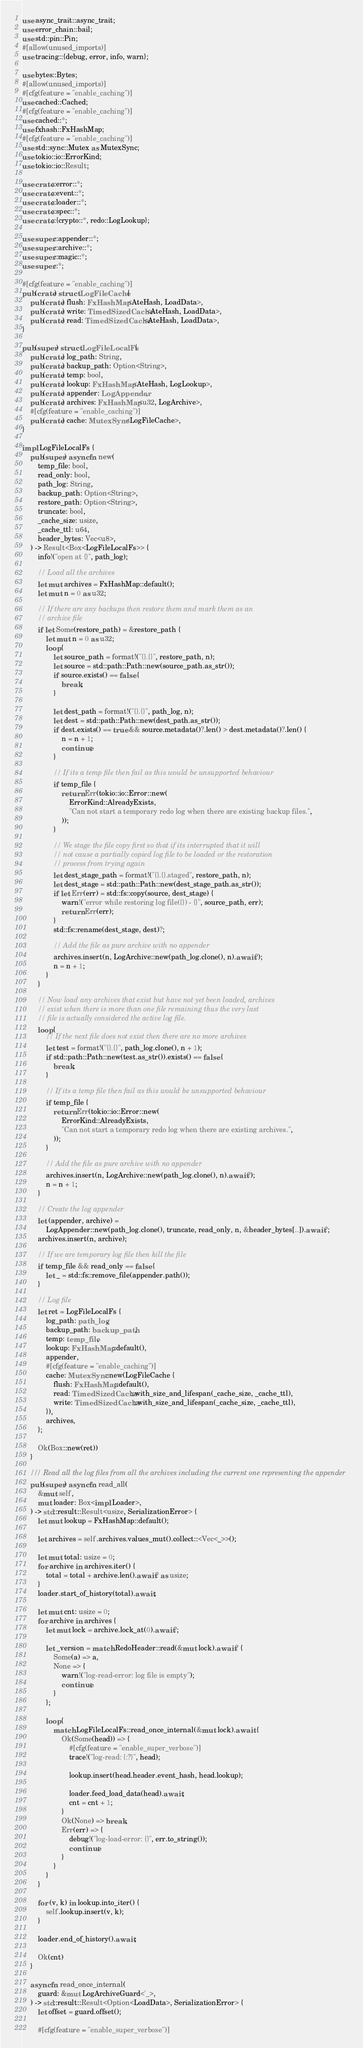Convert code to text. <code><loc_0><loc_0><loc_500><loc_500><_Rust_>use async_trait::async_trait;
use error_chain::bail;
use std::pin::Pin;
#[allow(unused_imports)]
use tracing::{debug, error, info, warn};

use bytes::Bytes;
#[allow(unused_imports)]
#[cfg(feature = "enable_caching")]
use cached::Cached;
#[cfg(feature = "enable_caching")]
use cached::*;
use fxhash::FxHashMap;
#[cfg(feature = "enable_caching")]
use std::sync::Mutex as MutexSync;
use tokio::io::ErrorKind;
use tokio::io::Result;

use crate::error::*;
use crate::event::*;
use crate::loader::*;
use crate::spec::*;
use crate::{crypto::*, redo::LogLookup};

use super::appender::*;
use super::archive::*;
use super::magic::*;
use super::*;

#[cfg(feature = "enable_caching")]
pub(crate) struct LogFileCache {
    pub(crate) flush: FxHashMap<AteHash, LoadData>,
    pub(crate) write: TimedSizedCache<AteHash, LoadData>,
    pub(crate) read: TimedSizedCache<AteHash, LoadData>,
}

pub(super) struct LogFileLocalFs {
    pub(crate) log_path: String,
    pub(crate) backup_path: Option<String>,
    pub(crate) temp: bool,
    pub(crate) lookup: FxHashMap<AteHash, LogLookup>,
    pub(crate) appender: LogAppender,
    pub(crate) archives: FxHashMap<u32, LogArchive>,
    #[cfg(feature = "enable_caching")]
    pub(crate) cache: MutexSync<LogFileCache>,
}

impl LogFileLocalFs {
    pub(super) async fn new(
        temp_file: bool,
        read_only: bool,
        path_log: String,
        backup_path: Option<String>,
        restore_path: Option<String>,
        truncate: bool,
        _cache_size: usize,
        _cache_ttl: u64,
        header_bytes: Vec<u8>,
    ) -> Result<Box<LogFileLocalFs>> {
        info!("open at {}", path_log);

        // Load all the archives
        let mut archives = FxHashMap::default();
        let mut n = 0 as u32;

        // If there are any backups then restore them and mark them as an
        // archive file
        if let Some(restore_path) = &restore_path {
            let mut n = 0 as u32;
            loop {
                let source_path = format!("{}.{}", restore_path, n);
                let source = std::path::Path::new(source_path.as_str());
                if source.exists() == false {
                    break;
                }

                let dest_path = format!("{}.{}", path_log, n);
                let dest = std::path::Path::new(dest_path.as_str());
                if dest.exists() == true && source.metadata()?.len() > dest.metadata()?.len() {
                    n = n + 1;
                    continue;
                }

                // If its a temp file then fail as this would be unsupported behaviour
                if temp_file {
                    return Err(tokio::io::Error::new(
                        ErrorKind::AlreadyExists,
                        "Can not start a temporary redo log when there are existing backup files.",
                    ));
                }

                // We stage the file copy first so that if its interrupted that it will
                // not cause a partially copied log file to be loaded or the restoration
                // process from trying again
                let dest_stage_path = format!("{}.{}.staged", restore_path, n);
                let dest_stage = std::path::Path::new(dest_stage_path.as_str());
                if let Err(err) = std::fs::copy(source, dest_stage) {
                    warn!("error while restoring log file({}) - {}", source_path, err);
                    return Err(err);
                }
                std::fs::rename(dest_stage, dest)?;

                // Add the file as pure archive with no appender
                archives.insert(n, LogArchive::new(path_log.clone(), n).await?);
                n = n + 1;
            }
        }

        // Now load any archives that exist but have not yet been loaded, archives
        // exist when there is more than one file remaining thus the very last
        // file is actually considered the active log file.
        loop {
            // If the next file does not exist then there are no more archives
            let test = format!("{}.{}", path_log.clone(), n + 1);
            if std::path::Path::new(test.as_str()).exists() == false {
                break;
            }

            // If its a temp file then fail as this would be unsupported behaviour
            if temp_file {
                return Err(tokio::io::Error::new(
                    ErrorKind::AlreadyExists,
                    "Can not start a temporary redo log when there are existing archives.",
                ));
            }

            // Add the file as pure archive with no appender
            archives.insert(n, LogArchive::new(path_log.clone(), n).await?);
            n = n + 1;
        }

        // Create the log appender
        let (appender, archive) =
            LogAppender::new(path_log.clone(), truncate, read_only, n, &header_bytes[..]).await?;
        archives.insert(n, archive);

        // If we are temporary log file then kill the file
        if temp_file && read_only == false {
            let _ = std::fs::remove_file(appender.path());
        }

        // Log file
        let ret = LogFileLocalFs {
            log_path: path_log,
            backup_path: backup_path,
            temp: temp_file,
            lookup: FxHashMap::default(),
            appender,
            #[cfg(feature = "enable_caching")]
            cache: MutexSync::new(LogFileCache {
                flush: FxHashMap::default(),
                read: TimedSizedCache::with_size_and_lifespan(_cache_size, _cache_ttl),
                write: TimedSizedCache::with_size_and_lifespan(_cache_size, _cache_ttl),
            }),
            archives,
        };

        Ok(Box::new(ret))
    }

    /// Read all the log files from all the archives including the current one representing the appender
    pub(super) async fn read_all(
        &mut self,
        mut loader: Box<impl Loader>,
    ) -> std::result::Result<usize, SerializationError> {
        let mut lookup = FxHashMap::default();

        let archives = self.archives.values_mut().collect::<Vec<_>>();

        let mut total: usize = 0;
        for archive in archives.iter() {
            total = total + archive.len().await? as usize;
        }
        loader.start_of_history(total).await;

        let mut cnt: usize = 0;
        for archive in archives {
            let mut lock = archive.lock_at(0).await?;

            let _version = match RedoHeader::read(&mut lock).await? {
                Some(a) => a,
                None => {
                    warn!("log-read-error: log file is empty");
                    continue;
                }
            };

            loop {
                match LogFileLocalFs::read_once_internal(&mut lock).await {
                    Ok(Some(head)) => {
                        #[cfg(feature = "enable_super_verbose")]
                        trace!("log-read: {:?}", head);

                        lookup.insert(head.header.event_hash, head.lookup);

                        loader.feed_load_data(head).await;
                        cnt = cnt + 1;
                    }
                    Ok(None) => break,
                    Err(err) => {
                        debug!("log-load-error: {}", err.to_string());
                        continue;
                    }
                }
            }
        }

        for (v, k) in lookup.into_iter() {
            self.lookup.insert(v, k);
        }

        loader.end_of_history().await;

        Ok(cnt)
    }

    async fn read_once_internal(
        guard: &mut LogArchiveGuard<'_>,
    ) -> std::result::Result<Option<LoadData>, SerializationError> {
        let offset = guard.offset();

        #[cfg(feature = "enable_super_verbose")]</code> 